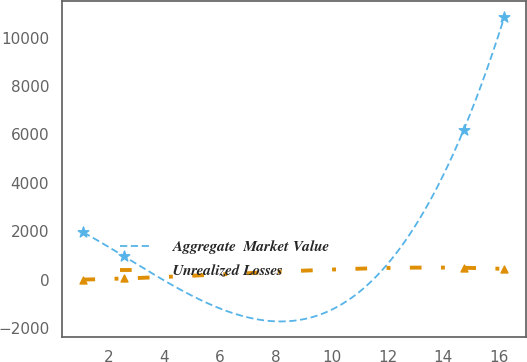Convert chart to OTSL. <chart><loc_0><loc_0><loc_500><loc_500><line_chart><ecel><fcel>Aggregate  Market Value<fcel>Unrealized Losses<nl><fcel>1.11<fcel>1948.67<fcel>0<nl><fcel>2.57<fcel>957.76<fcel>46.49<nl><fcel>14.73<fcel>6186.61<fcel>487.48<nl><fcel>16.19<fcel>10866.9<fcel>440.99<nl></chart> 